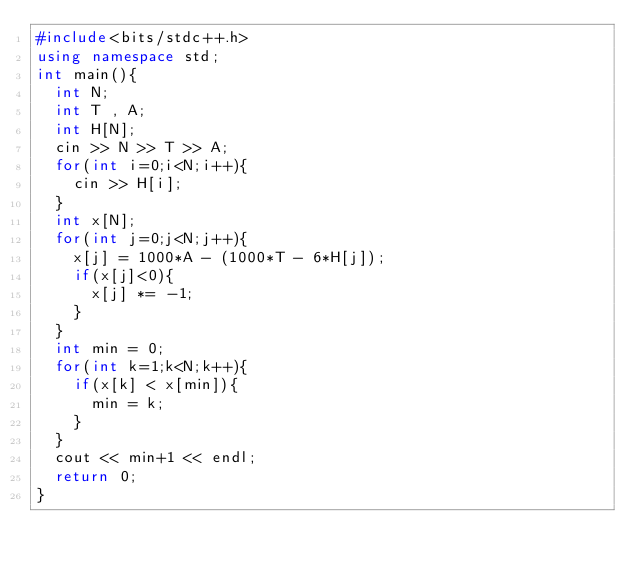<code> <loc_0><loc_0><loc_500><loc_500><_C++_>#include<bits/stdc++.h>
using namespace std;
int main(){
	int N;
	int T , A;
	int H[N];
	cin >> N >> T >> A;
	for(int i=0;i<N;i++){
		cin >> H[i];
	}
	int x[N];
	for(int j=0;j<N;j++){
		x[j] = 1000*A - (1000*T - 6*H[j]);
		if(x[j]<0){
			x[j] *= -1;
		}
	}
	int min = 0;
	for(int k=1;k<N;k++){
		if(x[k] < x[min]){
			min = k;
		}
	}
	cout << min+1 << endl;
	return 0;
}
		
		</code> 